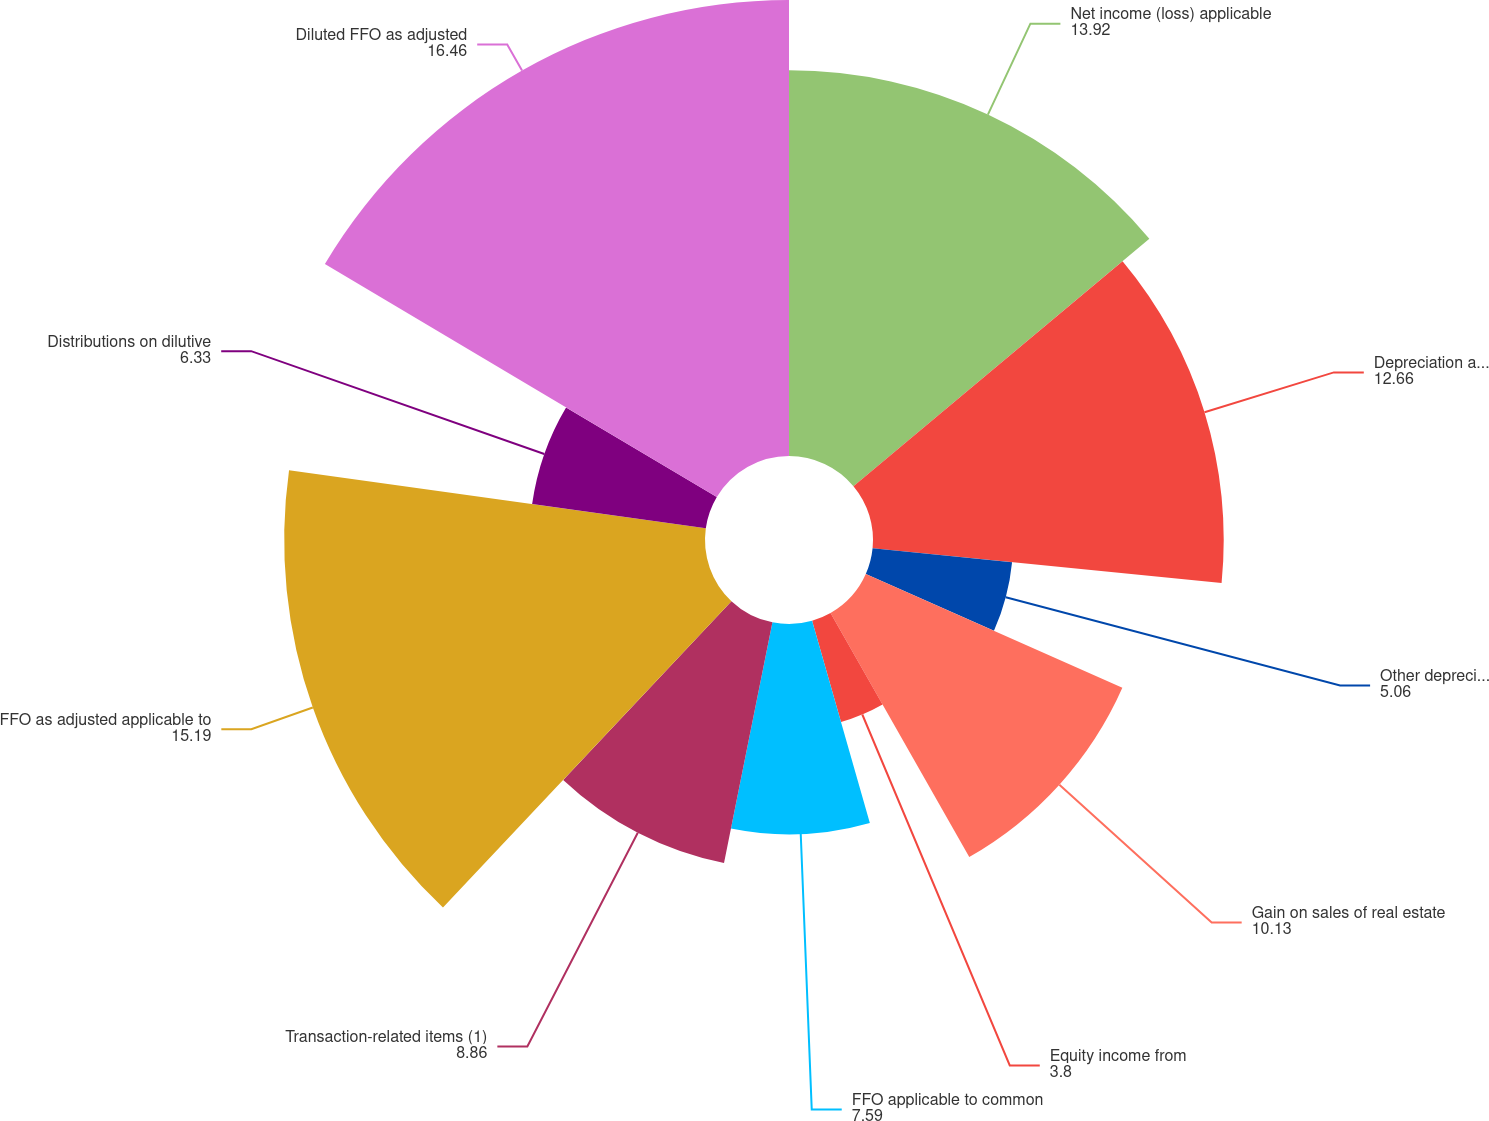Convert chart. <chart><loc_0><loc_0><loc_500><loc_500><pie_chart><fcel>Net income (loss) applicable<fcel>Depreciation and amortization<fcel>Other depreciation and<fcel>Gain on sales of real estate<fcel>Equity income from<fcel>FFO applicable to common<fcel>Transaction-related items (1)<fcel>FFO as adjusted applicable to<fcel>Distributions on dilutive<fcel>Diluted FFO as adjusted<nl><fcel>13.92%<fcel>12.66%<fcel>5.06%<fcel>10.13%<fcel>3.8%<fcel>7.59%<fcel>8.86%<fcel>15.19%<fcel>6.33%<fcel>16.46%<nl></chart> 